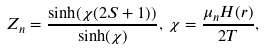<formula> <loc_0><loc_0><loc_500><loc_500>Z _ { n } = \frac { \sinh ( \chi ( 2 S + 1 ) ) } { \sinh ( \chi ) } , \, \chi = \frac { \mu _ { n } H ( r ) } { 2 T } ,</formula> 